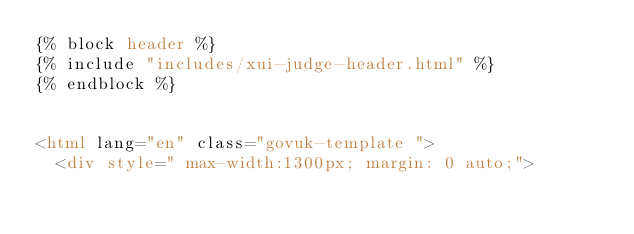<code> <loc_0><loc_0><loc_500><loc_500><_HTML_>{% block header %}
{% include "includes/xui-judge-header.html" %}
{% endblock %}


<html lang="en" class="govuk-template ">  
  <div style=" max-width:1300px; margin: 0 auto;"></code> 